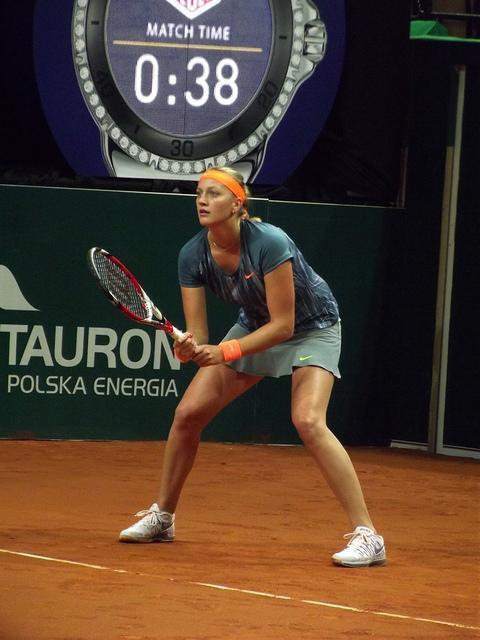How many people are holding umbrellas in the photo?
Give a very brief answer. 0. 